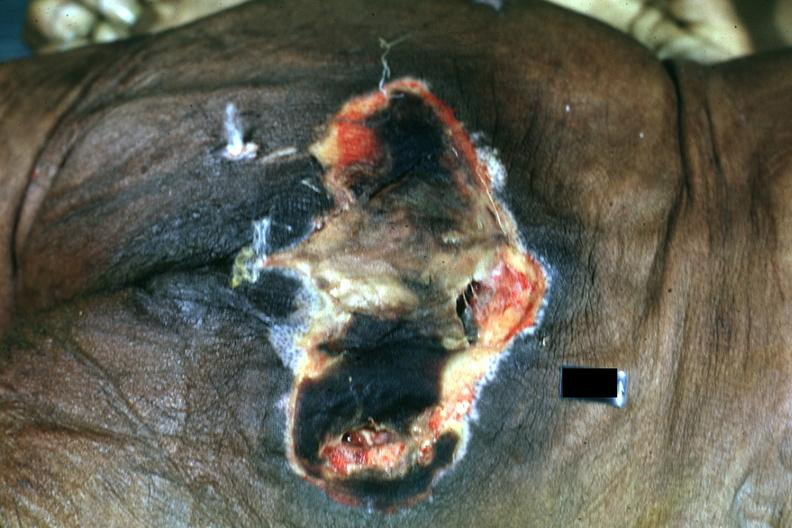does this image show large necrotic ulcer over sacrum?
Answer the question using a single word or phrase. Yes 